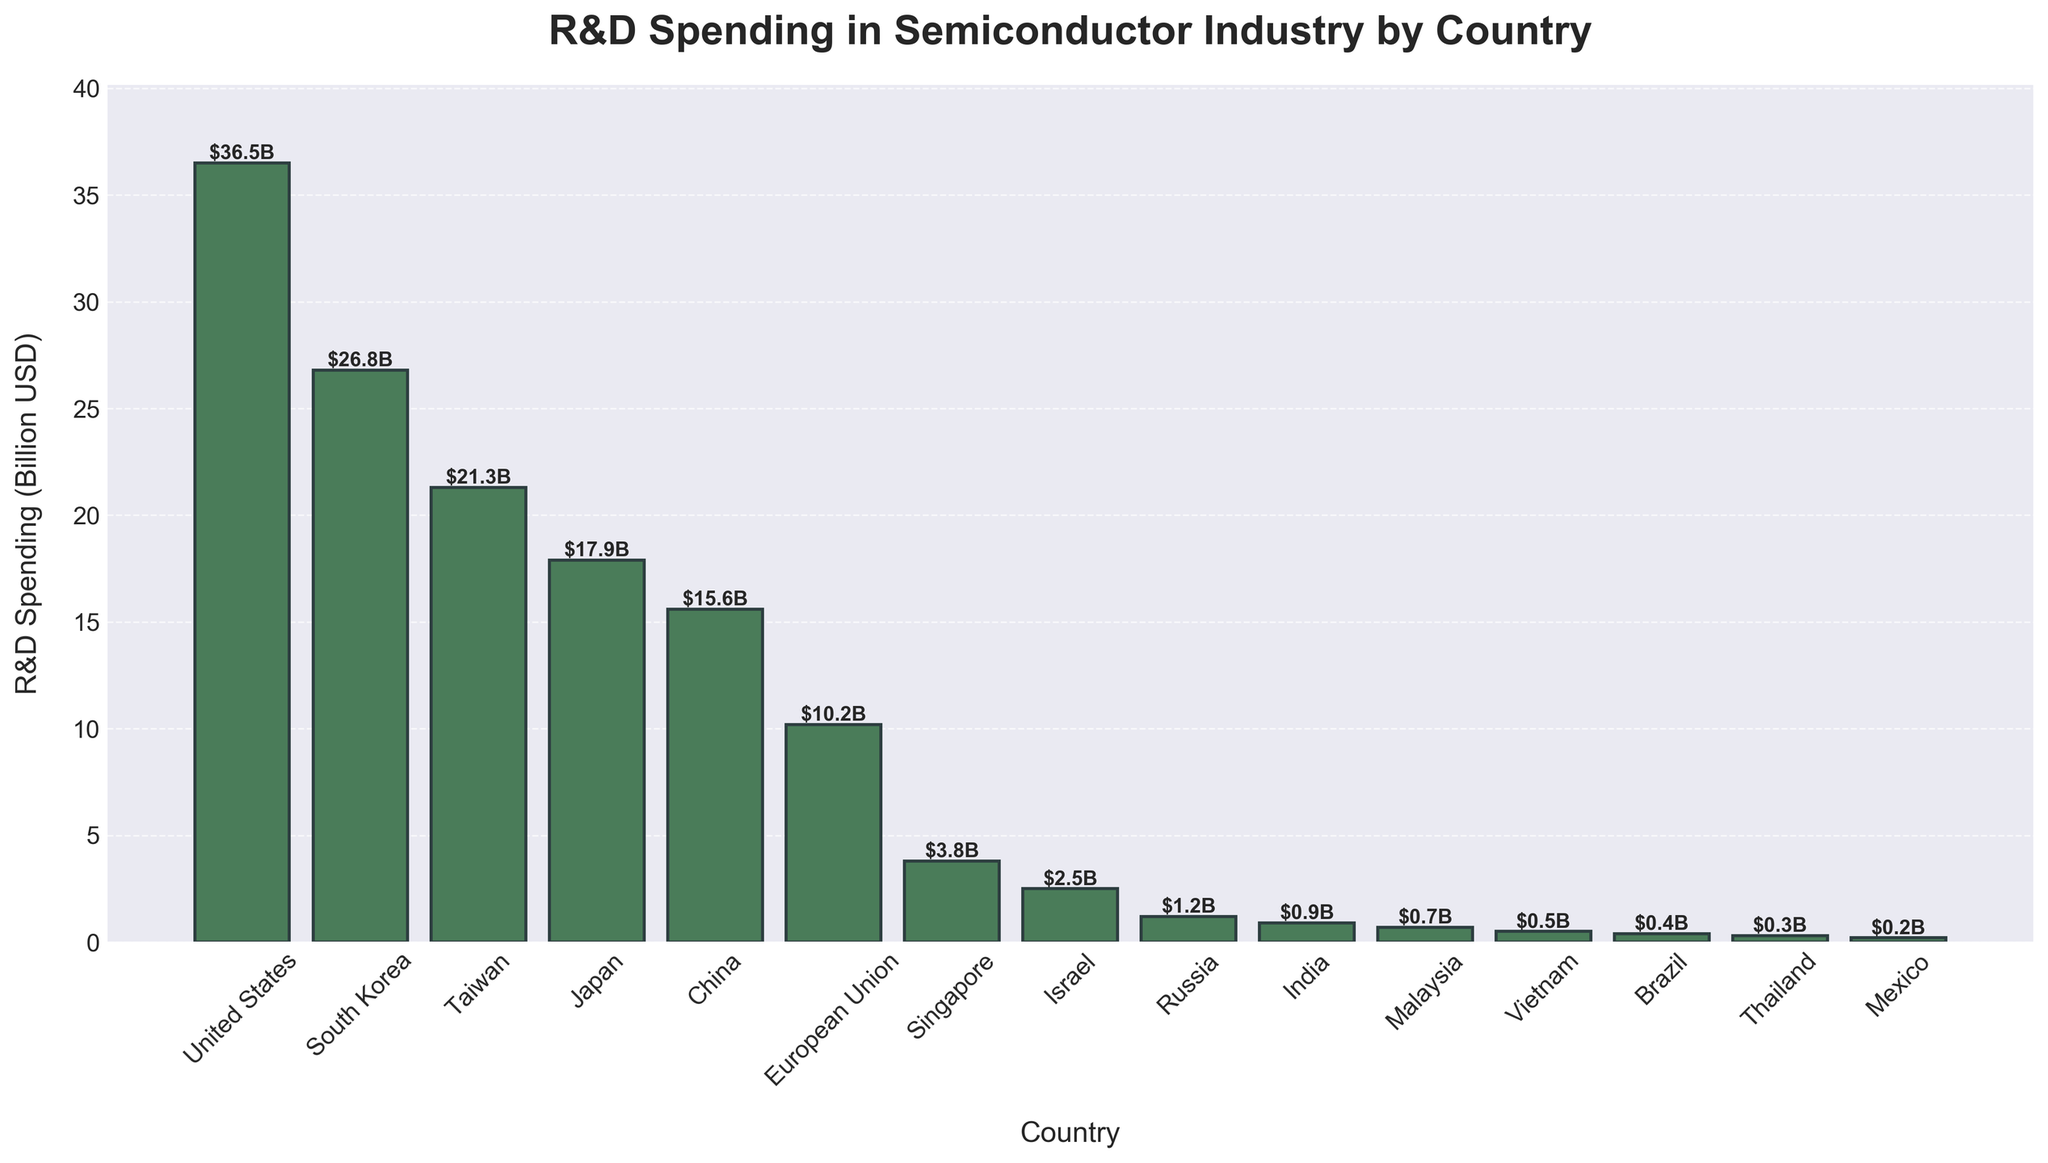Which country has the highest R&D spending in the semiconductor industry? By looking at the height of the bars, the United States has the tallest bar, indicating it has the highest R&D spending.
Answer: United States What is the total R&D spending for the top three countries? The R&D spending for the top three countries is United States ($36.5B), South Korea ($26.8B), and Taiwan ($21.3B). Adding these values together gives $36.5B + $26.8B + $21.3B = $84.6B.
Answer: $84.6B Which countries have an R&D spending greater than $20B? By comparing the heights of the bars, the countries with R&D spending greater than $20B are the United States, South Korea, and Taiwan.
Answer: United States, South Korea, Taiwan What is the difference in R&D spending between Japan and China? The R&D spending for Japan is $17.9B and for China is $15.6B. The difference is $17.9B - $15.6B = $2.3B.
Answer: $2.3B How many countries have an R&D spending less than $1B? By checking the heights of the bars and their corresponding values, the countries with R&D spending less than $1B are India, Malaysia, Vietnam, Brazil, Thailand, and Mexico. There are 6 such countries.
Answer: 6 Which is the country with the lowest R&D spending and what is the value? The shortest bar corresponds to Mexico, which has the lowest R&D spending of $0.2B.
Answer: Mexico, $0.2B What is the average R&D spending for the European Union, Singapore, and Israel? The R&D spending for European Union is $10.2B, Singapore is $3.8B, and Israel is $2.5B. The average is calculated as ($10.2B + $3.8B + $2.5B) / 3 = $16.5B / 3 = $5.5B.
Answer: $5.5B What is the combined R&D spending for countries in Asia? The countries in Asia listed are South Korea, Taiwan, Japan, China, Singapore, Israel, India, Malaysia, and Vietnam. Adding their R&D spendings: $26.8B + $21.3B + $17.9B + $15.6B + $3.8B + $2.5B + $0.9B + $0.7B + $0.5B = $90.0B.
Answer: $90.0B Between the United States and the European Union, which has a higher R&D spending and by how much? The R&D spending for the United States is $36.5B and for the European Union is $10.2B. The United States has a higher R&D spending by $36.5B - $10.2B = $26.3B.
Answer: United States, $26.3B 